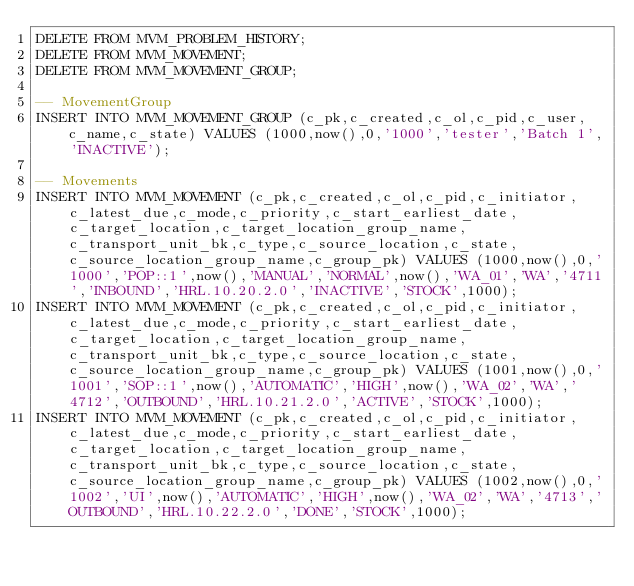Convert code to text. <code><loc_0><loc_0><loc_500><loc_500><_SQL_>DELETE FROM MVM_PROBLEM_HISTORY;
DELETE FROM MVM_MOVEMENT;
DELETE FROM MVM_MOVEMENT_GROUP;

-- MovementGroup
INSERT INTO MVM_MOVEMENT_GROUP (c_pk,c_created,c_ol,c_pid,c_user,c_name,c_state) VALUES (1000,now(),0,'1000','tester','Batch 1','INACTIVE');

-- Movements
INSERT INTO MVM_MOVEMENT (c_pk,c_created,c_ol,c_pid,c_initiator,c_latest_due,c_mode,c_priority,c_start_earliest_date,c_target_location,c_target_location_group_name,c_transport_unit_bk,c_type,c_source_location,c_state,c_source_location_group_name,c_group_pk) VALUES (1000,now(),0,'1000','POP::1',now(),'MANUAL','NORMAL',now(),'WA_01','WA','4711','INBOUND','HRL.10.20.2.0','INACTIVE','STOCK',1000);
INSERT INTO MVM_MOVEMENT (c_pk,c_created,c_ol,c_pid,c_initiator,c_latest_due,c_mode,c_priority,c_start_earliest_date,c_target_location,c_target_location_group_name,c_transport_unit_bk,c_type,c_source_location,c_state,c_source_location_group_name,c_group_pk) VALUES (1001,now(),0,'1001','SOP::1',now(),'AUTOMATIC','HIGH',now(),'WA_02','WA','4712','OUTBOUND','HRL.10.21.2.0','ACTIVE','STOCK',1000);
INSERT INTO MVM_MOVEMENT (c_pk,c_created,c_ol,c_pid,c_initiator,c_latest_due,c_mode,c_priority,c_start_earliest_date,c_target_location,c_target_location_group_name,c_transport_unit_bk,c_type,c_source_location,c_state,c_source_location_group_name,c_group_pk) VALUES (1002,now(),0,'1002','UI',now(),'AUTOMATIC','HIGH',now(),'WA_02','WA','4713','OUTBOUND','HRL.10.22.2.0','DONE','STOCK',1000);
</code> 